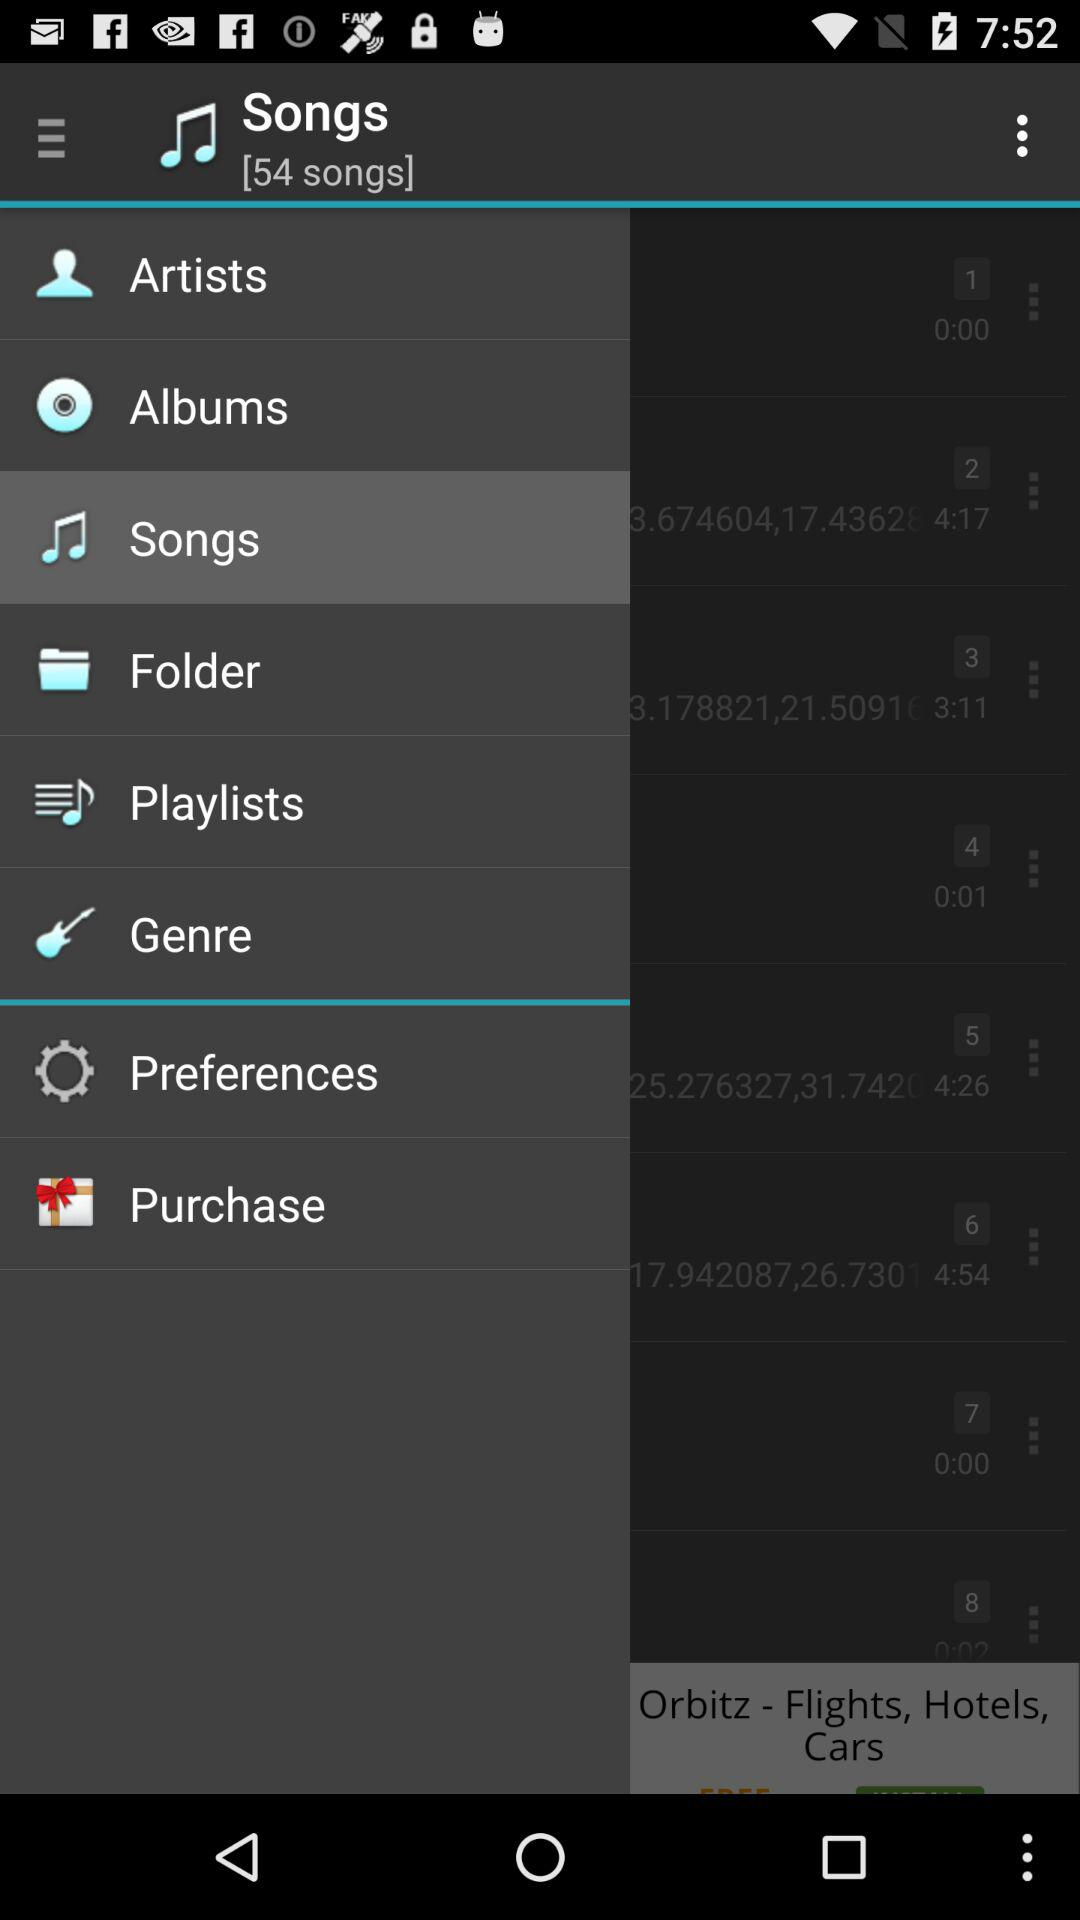Which item is selected? The selected item is "Songs". 